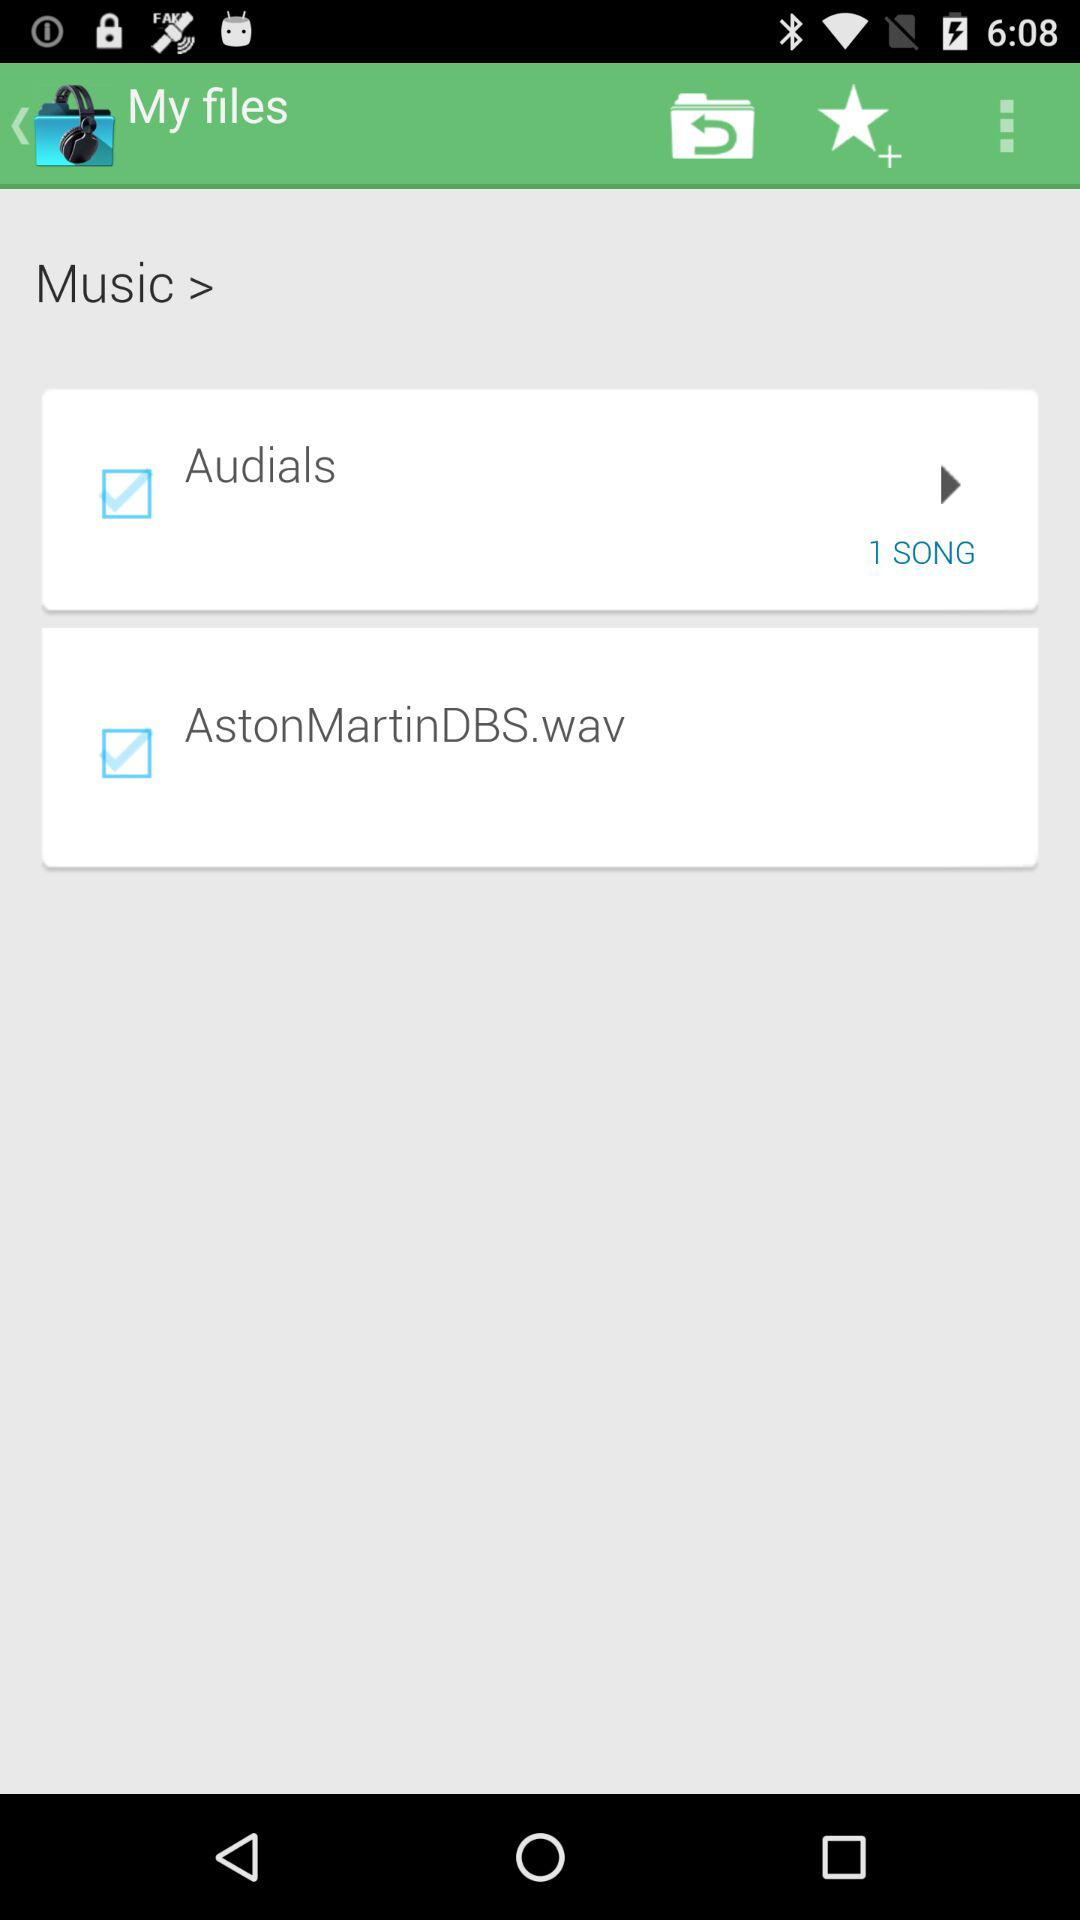How many more songs are there than checkboxes?
Answer the question using a single word or phrase. 1 